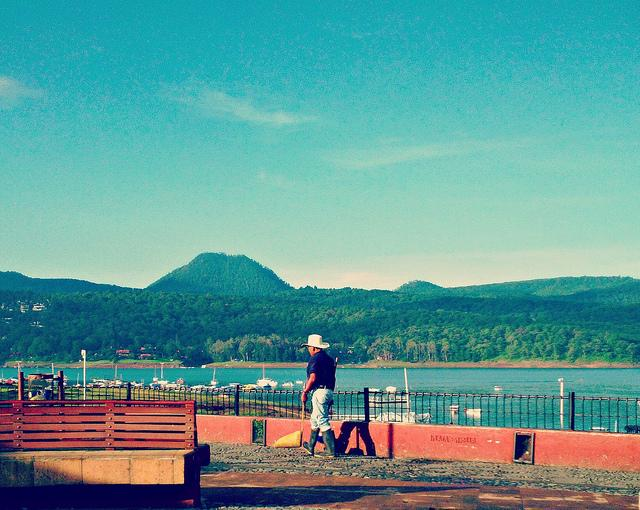What is the man wearing that is made of rubber? boots 